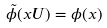Convert formula to latex. <formula><loc_0><loc_0><loc_500><loc_500>\tilde { \phi } ( x U ) = \phi ( x )</formula> 